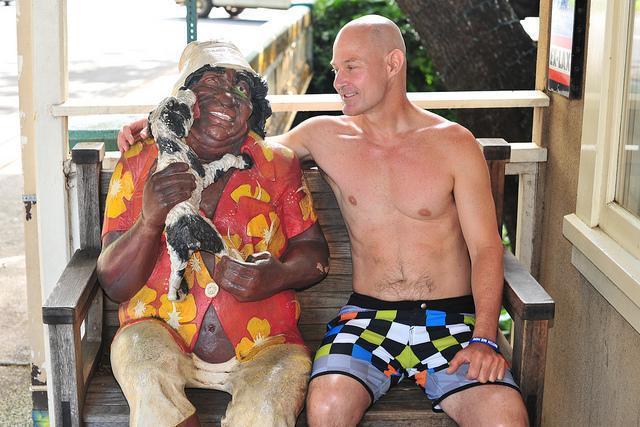How many people are there?
Give a very brief answer. 2. How many dogs are visible?
Give a very brief answer. 1. 